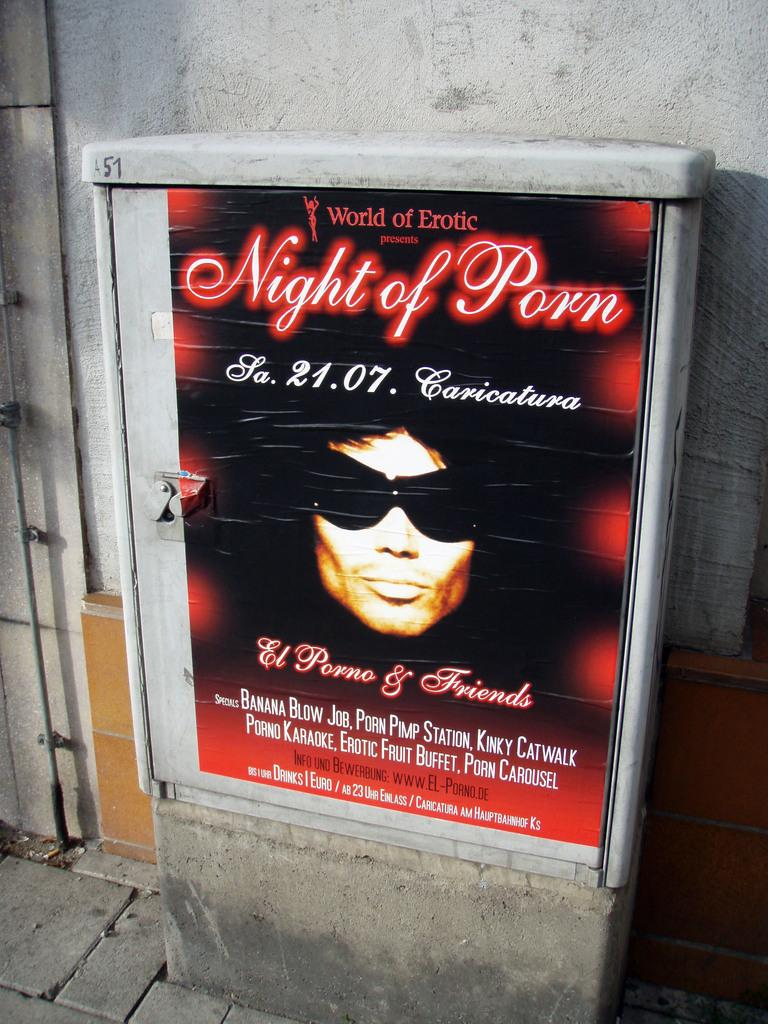<image>
Share a concise interpretation of the image provided. An advertisement for a Night of Porn features a man wearing sunglasses. 